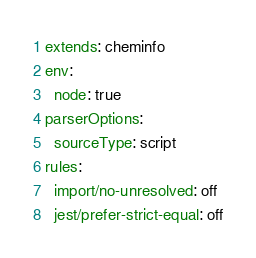Convert code to text. <code><loc_0><loc_0><loc_500><loc_500><_YAML_>extends: cheminfo
env:
  node: true
parserOptions:
  sourceType: script
rules:
  import/no-unresolved: off
  jest/prefer-strict-equal: off
</code> 